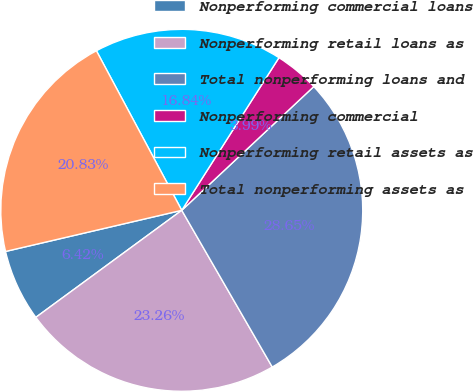<chart> <loc_0><loc_0><loc_500><loc_500><pie_chart><fcel>Nonperforming commercial loans<fcel>Nonperforming retail loans as<fcel>Total nonperforming loans and<fcel>Nonperforming commercial<fcel>Nonperforming retail assets as<fcel>Total nonperforming assets as<nl><fcel>6.42%<fcel>23.26%<fcel>28.65%<fcel>3.99%<fcel>16.84%<fcel>20.83%<nl></chart> 